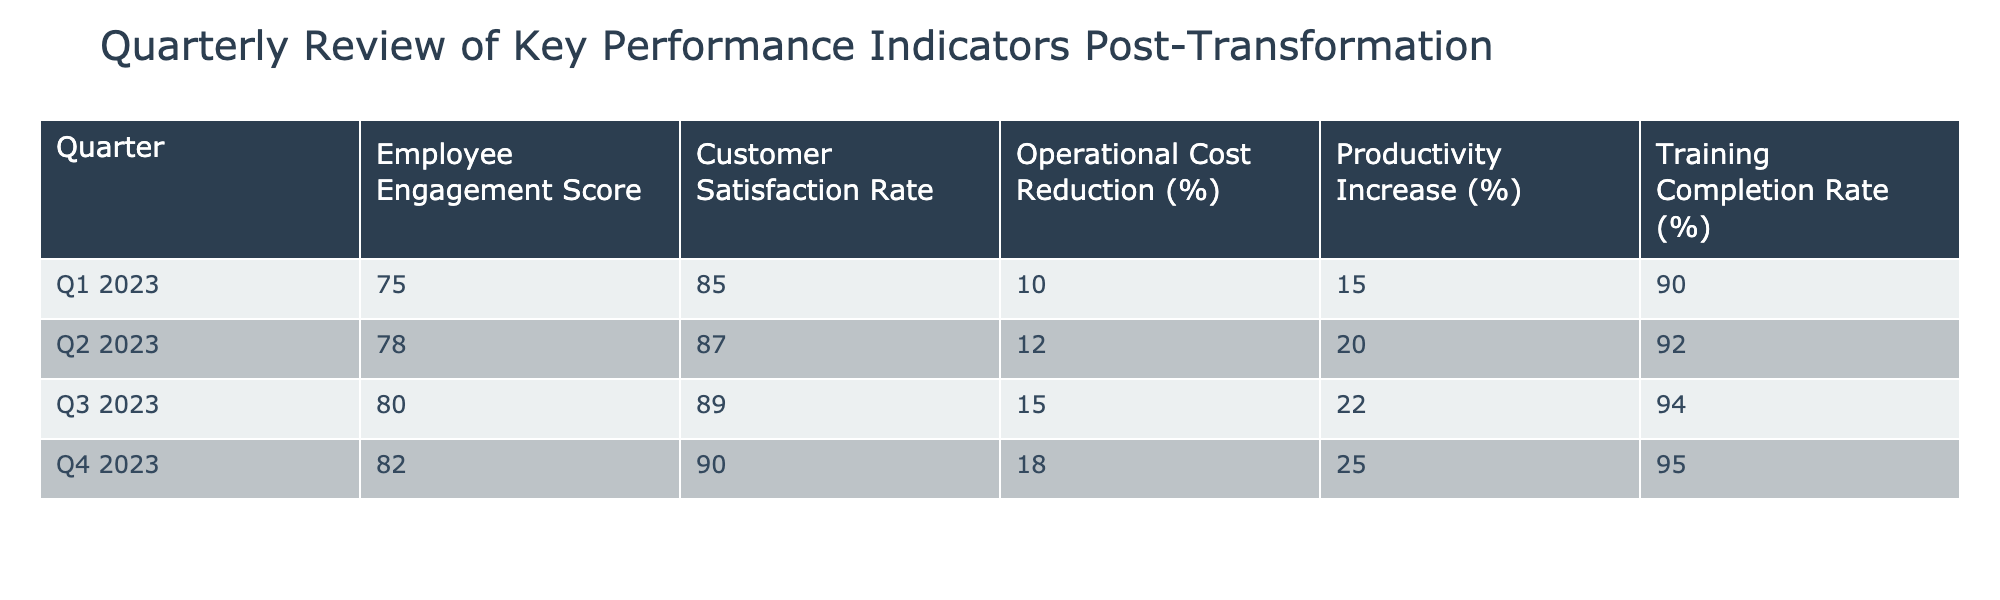What was the Employee Engagement Score in Q3 2023? The table shows the specific Employee Engagement Score for each quarter. In Q3 2023, the score listed is 80.
Answer: 80 What is the average Customer Satisfaction Rate across all quarters? To find the average, we add the Customer Satisfaction Rates for all quarters: (85 + 87 + 89 + 90) = 351. Then divide by the number of quarters (4): 351 / 4 = 87.75.
Answer: 87.75 Was there a decrease in Operational Cost Reduction from Q1 to Q2? Looking at the table, the Operational Cost Reduction for Q1 2023 is 10%, and for Q2 2023 it is 12%. Since 12% is greater than 10%, there was not a decrease.
Answer: No What was the increase in Productivity from Q2 to Q4? The Productivity Increase in Q2 is 20%, and in Q4 it is 25%. The difference is 25% - 20% = 5%.
Answer: 5% Which quarter had the highest Training Completion Rate, and what was that rate? By examining the Training Completion Rates for each quarter: Q1 is 90%, Q2 is 92%, Q3 is 94%, and Q4 is 95%. The highest rate is in Q4 2023 at 95%.
Answer: Q4 2023, 95% What is the percentage increase in Customer Satisfaction Rate from Q1 to Q4? The Customer Satisfaction Rate for Q1 is 85%, and for Q4 it is 90%. The increase is calculated as (90 - 85) / 85 * 100 = 5.88%.
Answer: 5.88% Is it true that the Employee Engagement Score increased in every quarter? Looking at the scores: Q1 is 75, Q2 is 78, Q3 is 80, and Q4 is 82. Each quarter shows a higher score than the previous one, confirming that the statement is true.
Answer: Yes What is the total Operational Cost Reduction percentage across all quarters? To find the total Operational Cost Reduction percentage, we add them: 10% + 12% + 15% + 18% = 55%.
Answer: 55% 